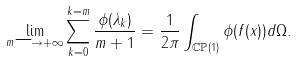Convert formula to latex. <formula><loc_0><loc_0><loc_500><loc_500>\lim _ { m \longrightarrow + \infty } \sum _ { k = 0 } ^ { k = m } \frac { \phi ( \lambda _ { k } ) } { m + 1 } = \frac { 1 } { 2 \pi } \int _ { \mathbb { C P } ( 1 ) } \phi ( f ( x ) ) d \Omega .</formula> 